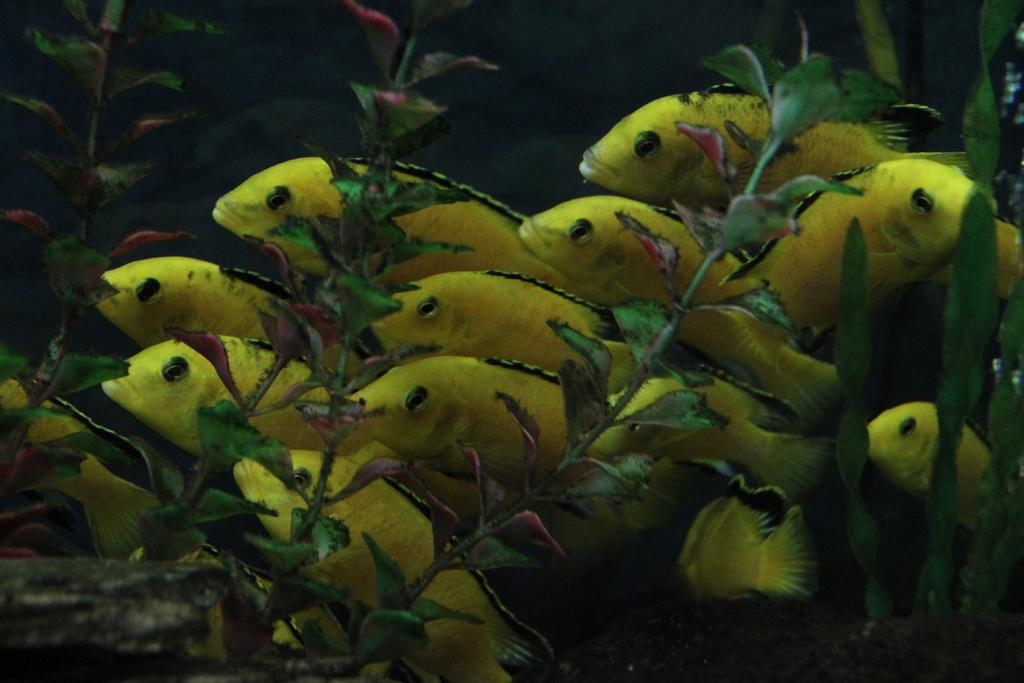What type of animals can be seen in the image? There are fish in the image. What other living organisms are present in the image? There are plants in the image. Where are the fish and plants located? The fish and plants are in the water. What type of toy can be seen floating in the water in the image? There is no toy present in the image; it features fish and plants in the water. What type of hose is connected to the plants in the image? There is no hose connected to the plants in the image; it only shows fish and plants in the water. 